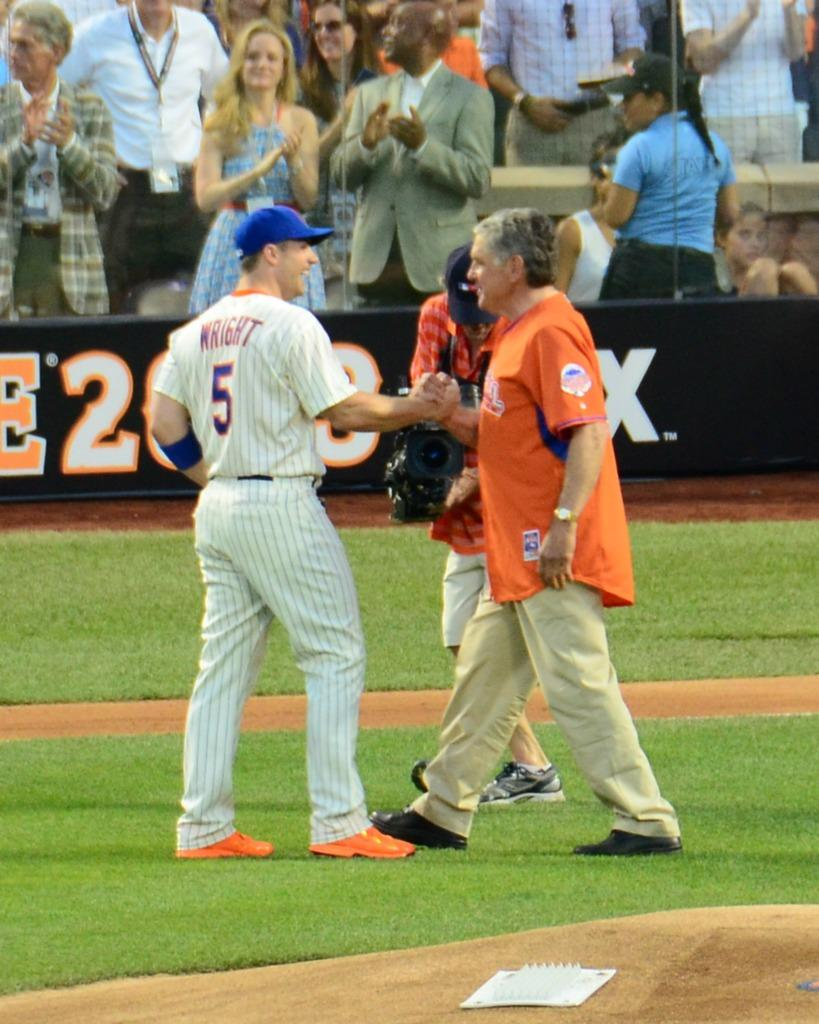<image>
Render a clear and concise summary of the photo. A baseball player named Wright shakes a man'ds hand while a cameraman films. 